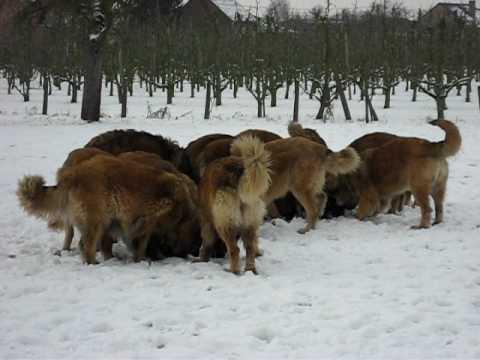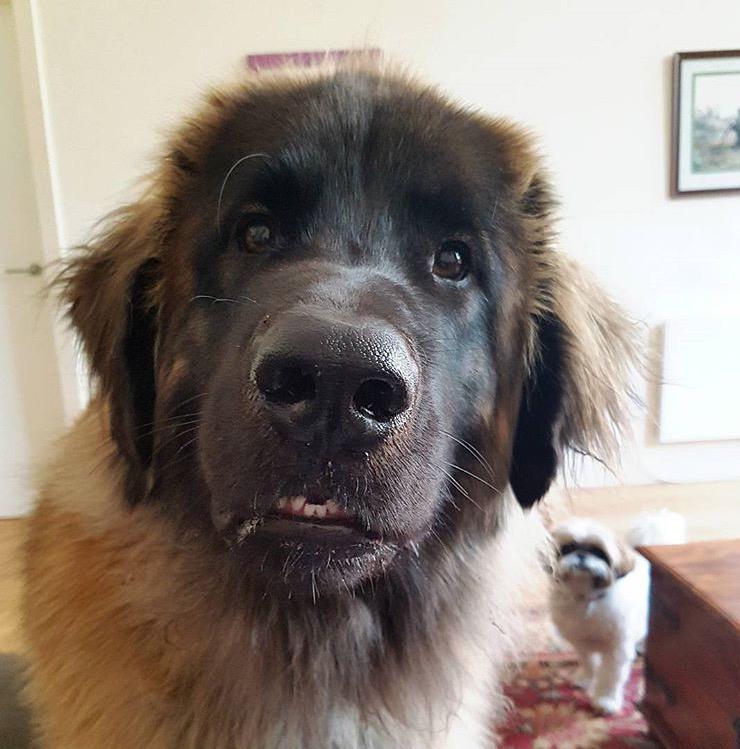The first image is the image on the left, the second image is the image on the right. For the images displayed, is the sentence "One image in the pair is an outdoor scene, while the other is clearly indoors." factually correct? Answer yes or no. Yes. 